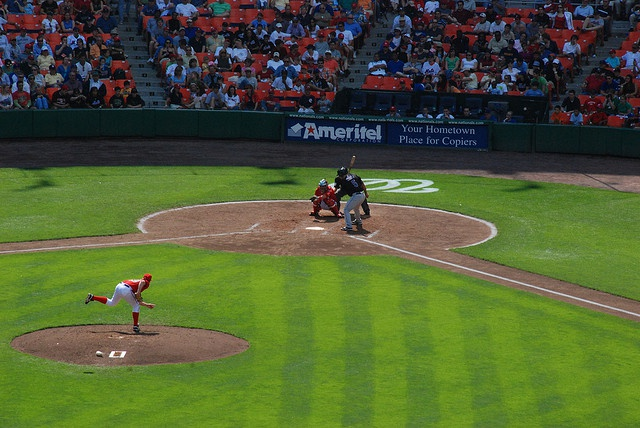Describe the objects in this image and their specific colors. I can see people in black, maroon, navy, and gray tones, people in black, maroon, and gray tones, people in black and gray tones, people in black, maroon, gray, and brown tones, and people in black, maroon, gray, and darkgreen tones in this image. 